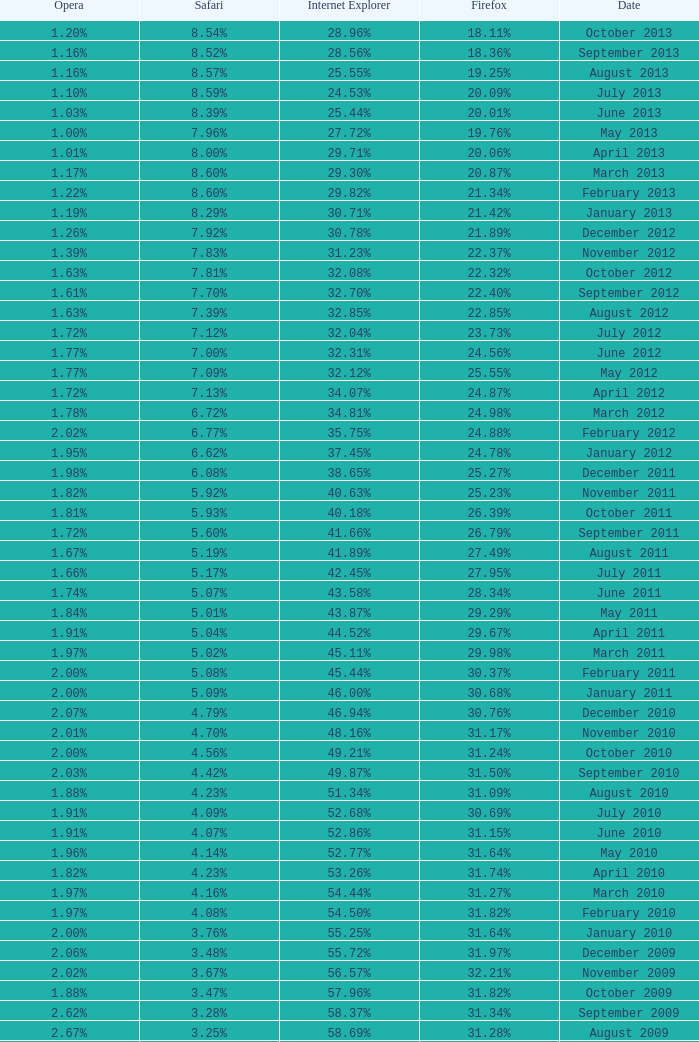What percentage of browsers were using Opera in October 2010? 2.00%. 